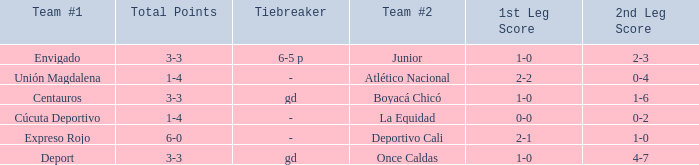What is the 1st leg with a junior team #2? 1–0. 